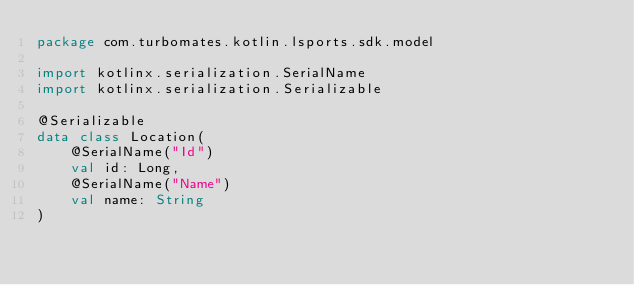<code> <loc_0><loc_0><loc_500><loc_500><_Kotlin_>package com.turbomates.kotlin.lsports.sdk.model

import kotlinx.serialization.SerialName
import kotlinx.serialization.Serializable

@Serializable
data class Location(
    @SerialName("Id")
    val id: Long,
    @SerialName("Name")
    val name: String
)
</code> 